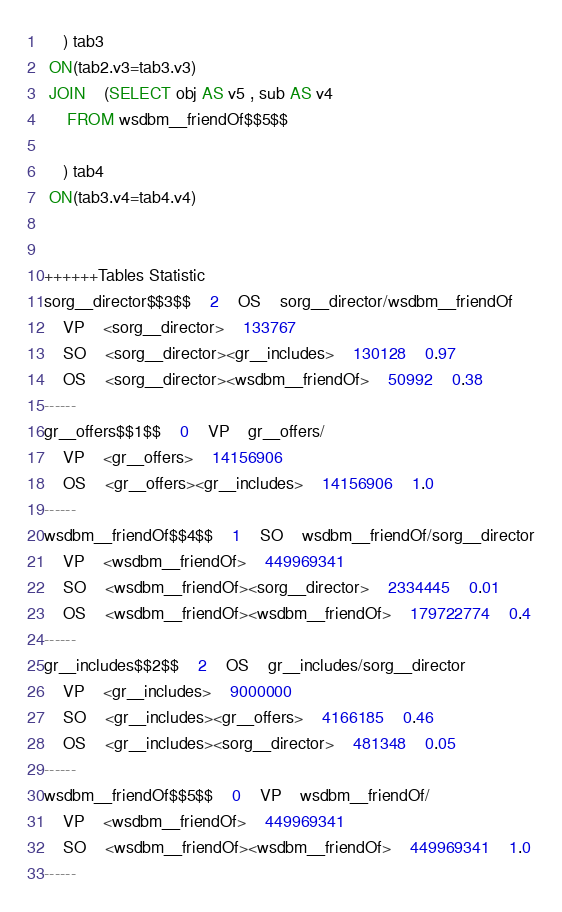Convert code to text. <code><loc_0><loc_0><loc_500><loc_500><_SQL_>	) tab3
 ON(tab2.v3=tab3.v3)
 JOIN    (SELECT obj AS v5 , sub AS v4 
	 FROM wsdbm__friendOf$$5$$
	
	) tab4
 ON(tab3.v4=tab4.v4)


++++++Tables Statistic
sorg__director$$3$$	2	OS	sorg__director/wsdbm__friendOf
	VP	<sorg__director>	133767
	SO	<sorg__director><gr__includes>	130128	0.97
	OS	<sorg__director><wsdbm__friendOf>	50992	0.38
------
gr__offers$$1$$	0	VP	gr__offers/
	VP	<gr__offers>	14156906
	OS	<gr__offers><gr__includes>	14156906	1.0
------
wsdbm__friendOf$$4$$	1	SO	wsdbm__friendOf/sorg__director
	VP	<wsdbm__friendOf>	449969341
	SO	<wsdbm__friendOf><sorg__director>	2334445	0.01
	OS	<wsdbm__friendOf><wsdbm__friendOf>	179722774	0.4
------
gr__includes$$2$$	2	OS	gr__includes/sorg__director
	VP	<gr__includes>	9000000
	SO	<gr__includes><gr__offers>	4166185	0.46
	OS	<gr__includes><sorg__director>	481348	0.05
------
wsdbm__friendOf$$5$$	0	VP	wsdbm__friendOf/
	VP	<wsdbm__friendOf>	449969341
	SO	<wsdbm__friendOf><wsdbm__friendOf>	449969341	1.0
------
</code> 